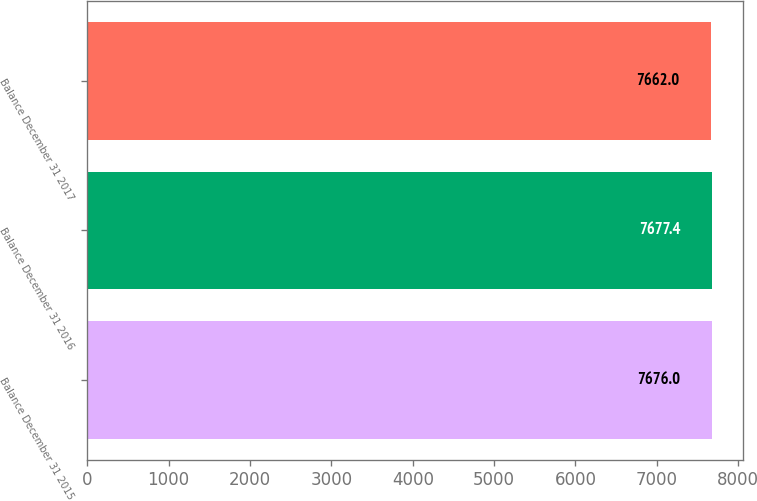<chart> <loc_0><loc_0><loc_500><loc_500><bar_chart><fcel>Balance December 31 2015<fcel>Balance December 31 2016<fcel>Balance December 31 2017<nl><fcel>7676<fcel>7677.4<fcel>7662<nl></chart> 